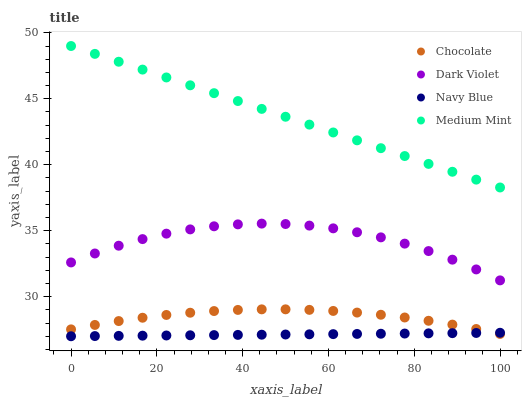Does Navy Blue have the minimum area under the curve?
Answer yes or no. Yes. Does Medium Mint have the maximum area under the curve?
Answer yes or no. Yes. Does Dark Violet have the minimum area under the curve?
Answer yes or no. No. Does Dark Violet have the maximum area under the curve?
Answer yes or no. No. Is Navy Blue the smoothest?
Answer yes or no. Yes. Is Dark Violet the roughest?
Answer yes or no. Yes. Is Dark Violet the smoothest?
Answer yes or no. No. Is Navy Blue the roughest?
Answer yes or no. No. Does Navy Blue have the lowest value?
Answer yes or no. Yes. Does Dark Violet have the lowest value?
Answer yes or no. No. Does Medium Mint have the highest value?
Answer yes or no. Yes. Does Dark Violet have the highest value?
Answer yes or no. No. Is Navy Blue less than Dark Violet?
Answer yes or no. Yes. Is Medium Mint greater than Chocolate?
Answer yes or no. Yes. Does Navy Blue intersect Chocolate?
Answer yes or no. Yes. Is Navy Blue less than Chocolate?
Answer yes or no. No. Is Navy Blue greater than Chocolate?
Answer yes or no. No. Does Navy Blue intersect Dark Violet?
Answer yes or no. No. 